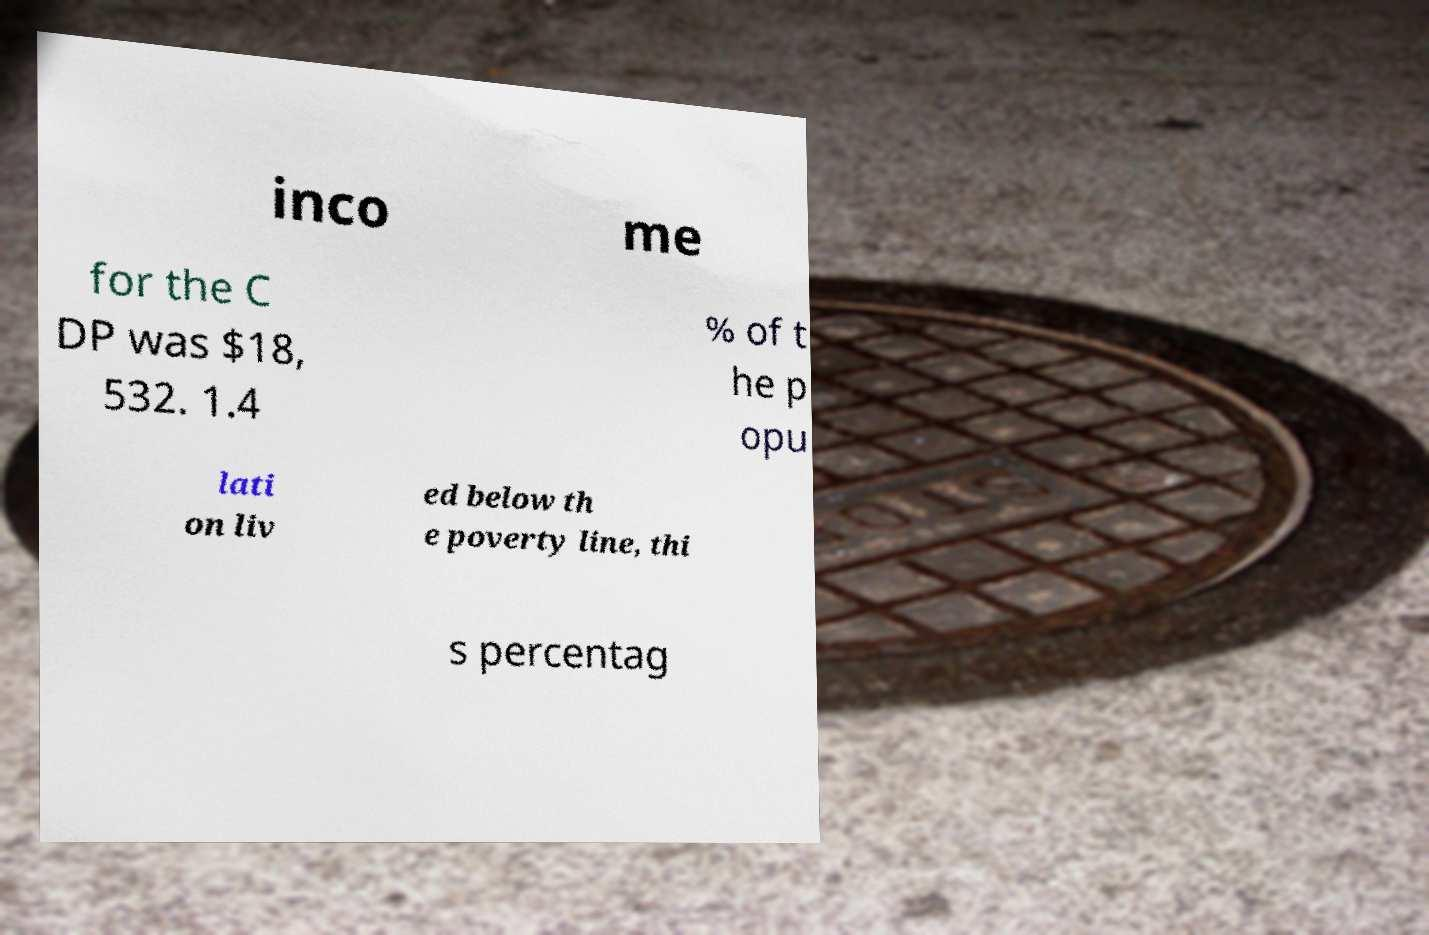For documentation purposes, I need the text within this image transcribed. Could you provide that? inco me for the C DP was $18, 532. 1.4 % of t he p opu lati on liv ed below th e poverty line, thi s percentag 